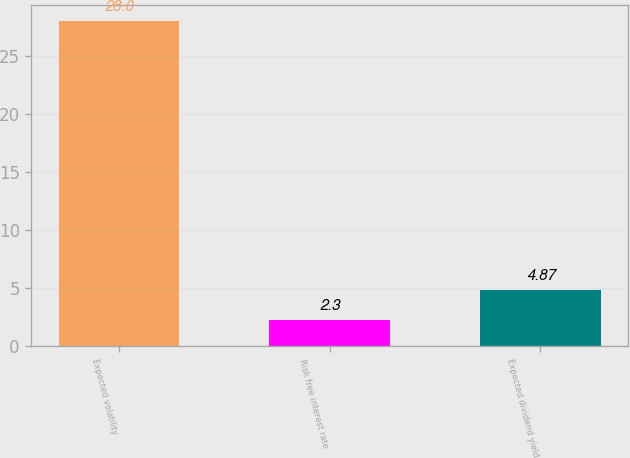Convert chart to OTSL. <chart><loc_0><loc_0><loc_500><loc_500><bar_chart><fcel>Expected volatility<fcel>Risk free interest rate<fcel>Expected dividend yield<nl><fcel>28<fcel>2.3<fcel>4.87<nl></chart> 